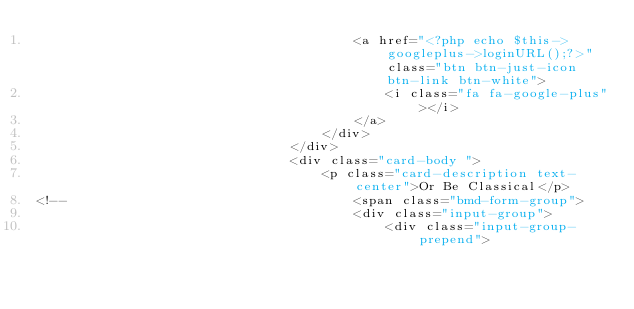Convert code to text. <code><loc_0><loc_0><loc_500><loc_500><_PHP_>                                        <a href="<?php echo $this->googleplus->loginURL();?>" class="btn btn-just-icon btn-link btn-white">
                                            <i class="fa fa-google-plus"></i>
                                        </a>
                                    </div>
                                </div>
                                <div class="card-body ">
                                    <p class="card-description text-center">Or Be Classical</p>
<!--                                    <span class="bmd-form-group">
                                        <div class="input-group">
                                            <div class="input-group-prepend"></code> 